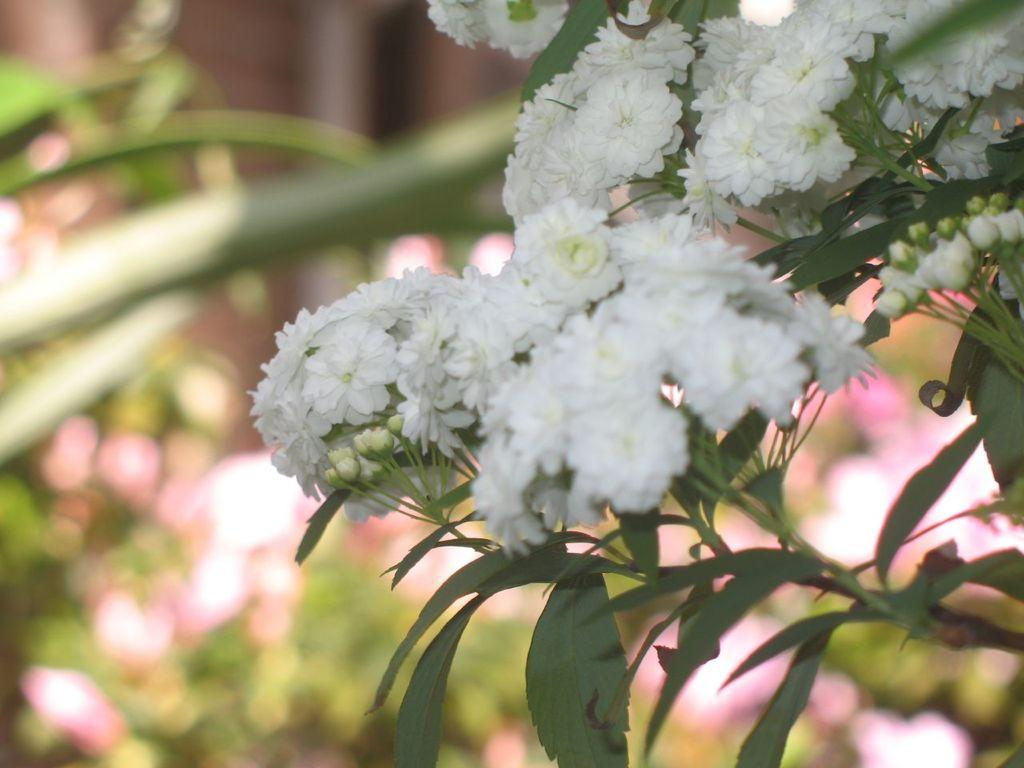What type of flowers can be seen on the plant in the image? There are small white color flowers on a plant in the image. What can be observed about the flowers in the background of the image? There are plants with different color flowers in the background of the image. What religion is being practiced by the creator of the flowers in the image? There is no information about the creator of the flowers or their religious beliefs in the image. 